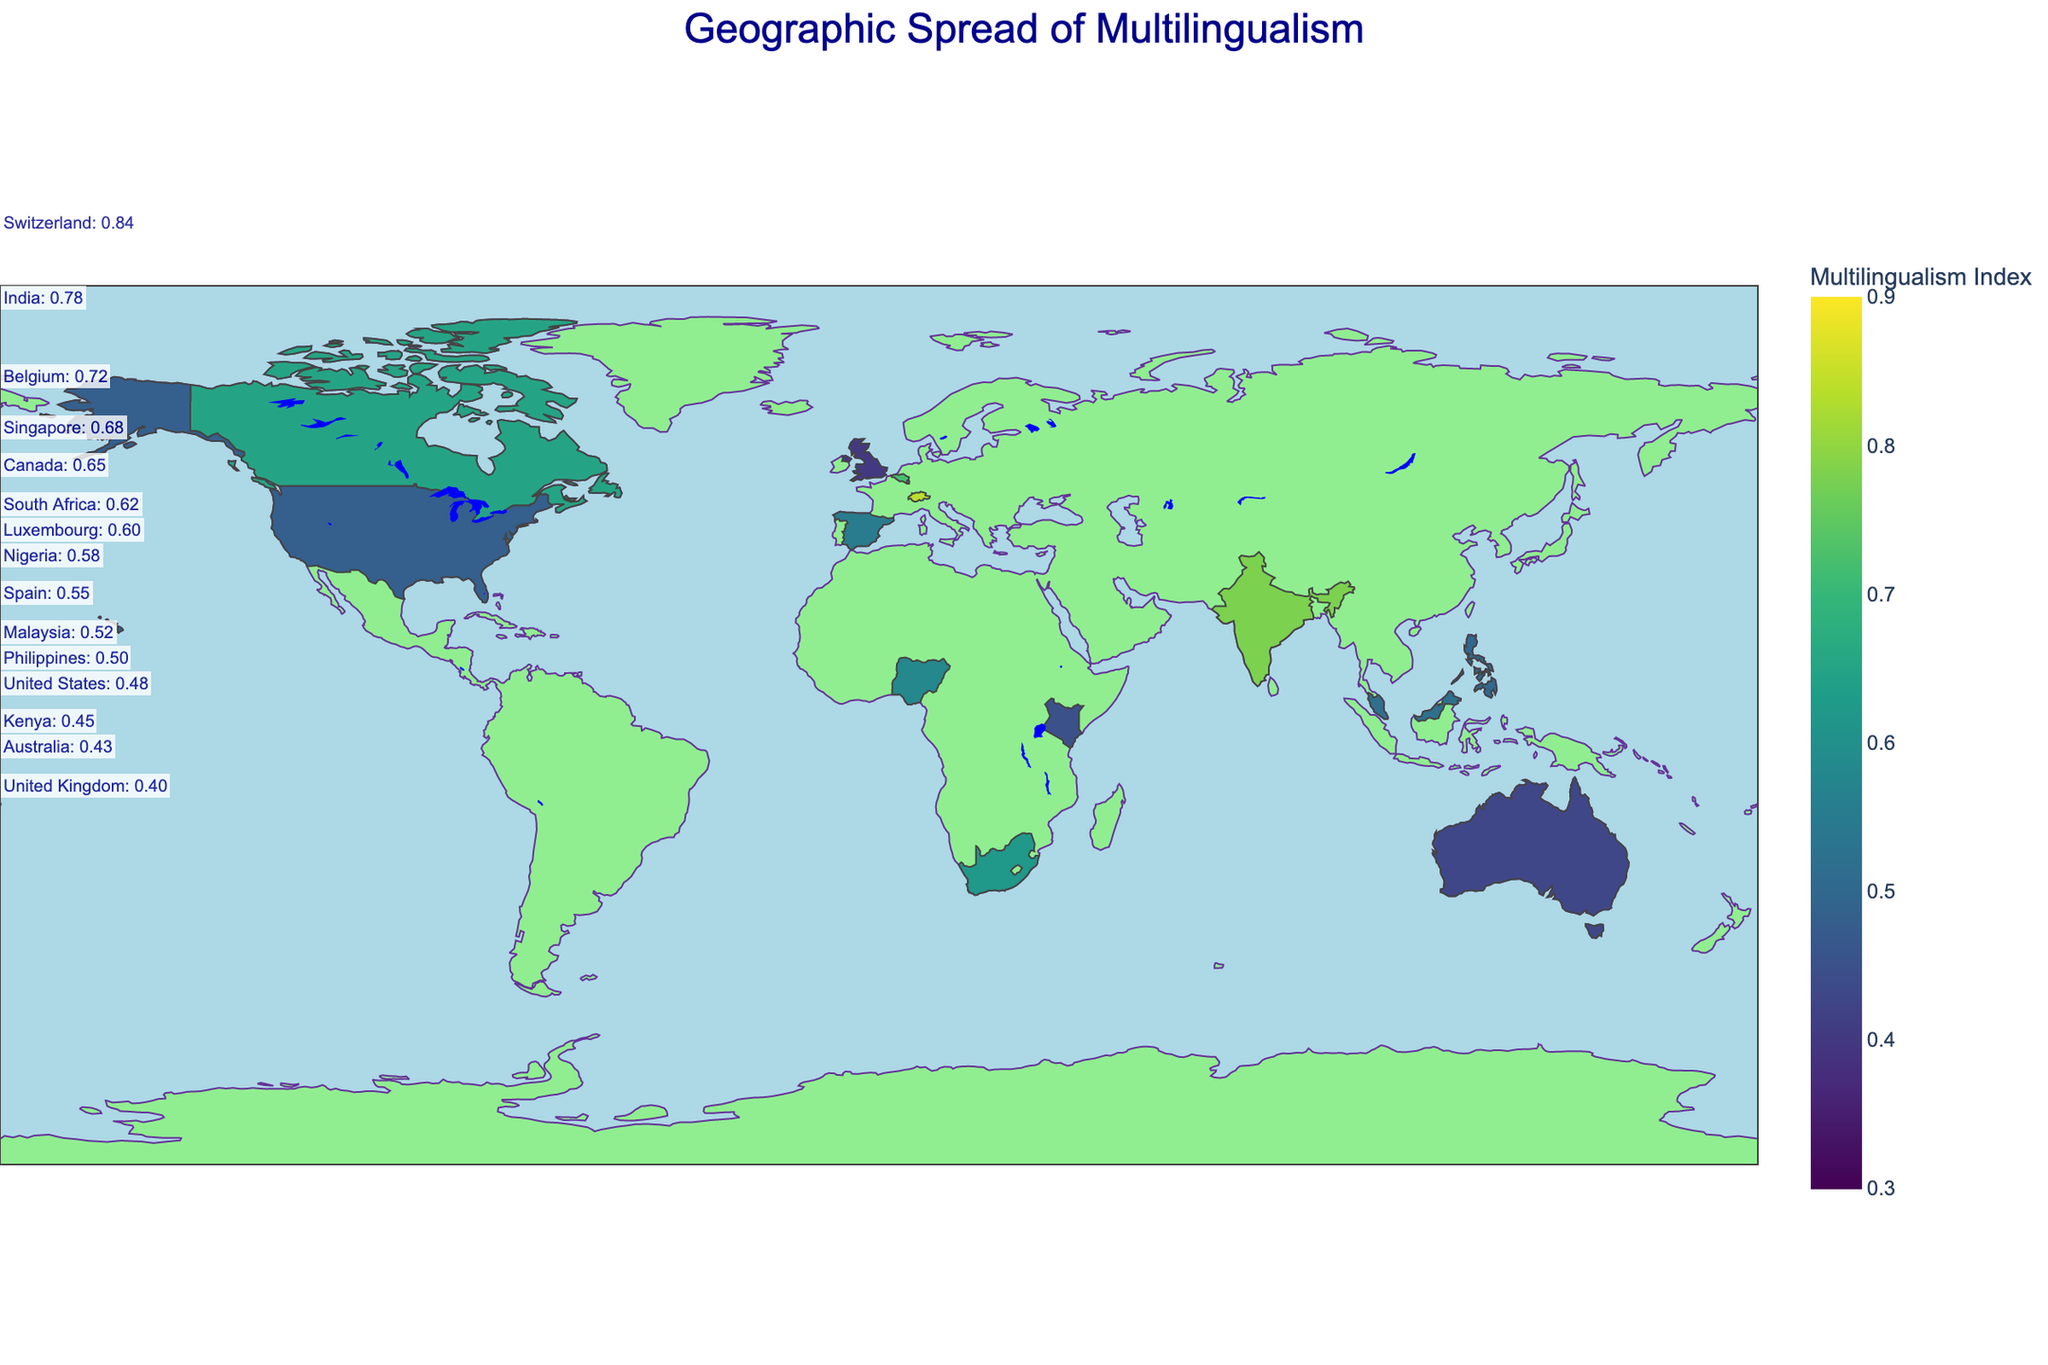Which country has the highest Multilingualism Index? The Multilingualism Index is represented by the color intensity on the plot, where darker shades indicate higher values. By observing the plot, Switzerland has the highest index with a noticeable dark shade.
Answer: Switzerland What is the range of the Multilingualism Index shown in the plot? The color legend indicates that the Multilingualism Index ranges from 0.3 to 0.9, as represented by the color scale on the right side of the plot.
Answer: 0.3 to 0.9 How many major languages are spoken in Canada according to the plot? By hovering over Canada on the plot, the data shows that there are two major languages spoken: English and French.
Answer: 2 Which countries have a Multilingualism Index greater than 0.7? By looking at the color intensities, Switzerland, India, and Belgium have darker colors indicating a Multilingualism Index greater than 0.7.
Answer: Switzerland, India, Belgium Compare the Multilingualism Index of Spain and Nigeria. Which one is higher? Observing the color intensities, Spain has a lighter shade compared to Nigeria, indicating a lower Multilingualism Index.
Answer: Nigeria What is the Multilingualism Index of the United States? Hovering over the United States on the plot reveals its Multilingualism Index which is 0.48.
Answer: 0.48 Which country has the lowest Multilingualism Index and what is its major language composition? The United Kingdom has the lowest Multilingualism Index as evidenced by the lightest color. Its major languages are English, Welsh, Scots, Polish, and Punjabi.
Answer: United Kingdom; English, Welsh, Scots, Polish, Punjabi What is the sum of the Multilingualism Indices of Kenya and Australia? Kenya's index is 0.45 and Australia's is 0.43. Adding them together, 0.45 + 0.43, equals 0.88.
Answer: 0.88 How many countries have exactly four major languages listed according to the plot? By examining the 'Major_Languages' column, countries with exactly four major languages are South Africa, Malaysia, and the United States. This makes a total of three countries.
Answer: 3 Describe the geographic distribution of multilingualism. Are there regions that tend to have higher or lower Multilingualism Index values? Observing the plot, European countries like Switzerland and Belgium, and South Asian countries like India, tend to have higher Multilingualism Index values. Meanwhile, English-speaking countries like the United States, United Kingdom, and Australia tend to have lower values. This suggests a regional variance where central Europe and multicultural regions in Asia have higher multilingualism.
Answer: Europe and South Asia higher; English-speaking countries lower 